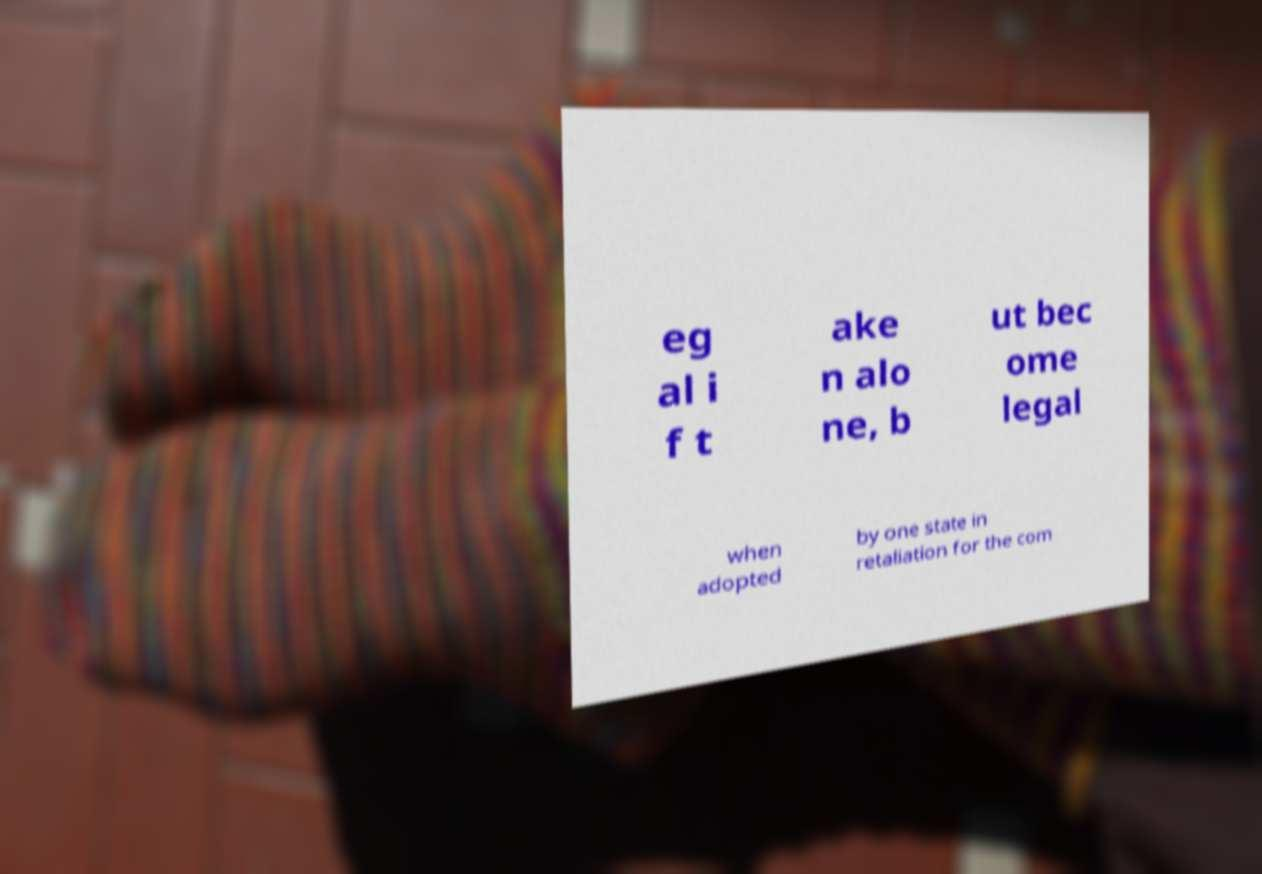Please identify and transcribe the text found in this image. eg al i f t ake n alo ne, b ut bec ome legal when adopted by one state in retaliation for the com 